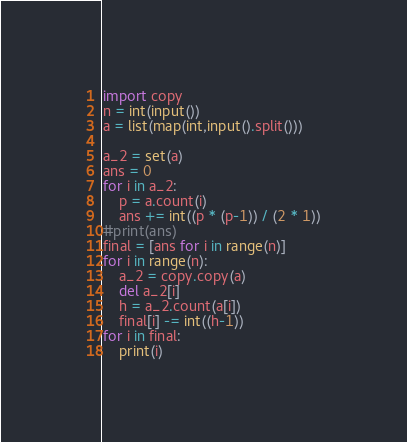<code> <loc_0><loc_0><loc_500><loc_500><_Python_>import copy
n = int(input())
a = list(map(int,input().split()))

a_2 = set(a)
ans = 0
for i in a_2:
    p = a.count(i)
    ans += int((p * (p-1)) / (2 * 1))
#print(ans)
final = [ans for i in range(n)]
for i in range(n):
    a_2 = copy.copy(a)
    del a_2[i]
    h = a_2.count(a[i])
    final[i] -= int((h-1))
for i in final:
    print(i)
</code> 